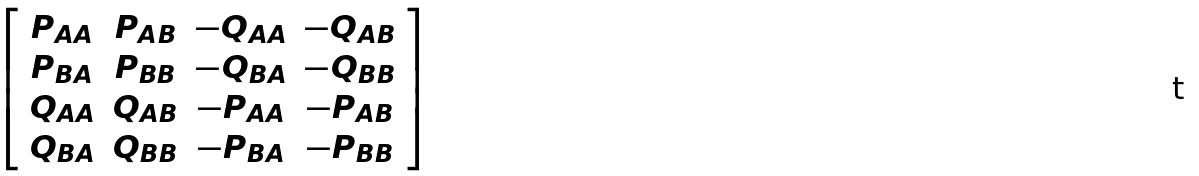<formula> <loc_0><loc_0><loc_500><loc_500>\left [ \begin{array} { c c c c } P _ { A A } & P _ { A B } & - Q _ { A A } & - Q _ { A B } \\ P _ { B A } & P _ { B B } & - Q _ { B A } & - Q _ { B B } \\ Q _ { A A } & Q _ { A B } & - P _ { A A } & - P _ { A B } \\ Q _ { B A } & Q _ { B B } & - P _ { B A } & - P _ { B B } \end{array} \right ]</formula> 